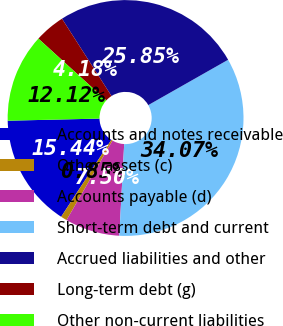Convert chart. <chart><loc_0><loc_0><loc_500><loc_500><pie_chart><fcel>Accounts and notes receivable<fcel>Other assets (c)<fcel>Accounts payable (d)<fcel>Short-term debt and current<fcel>Accrued liabilities and other<fcel>Long-term debt (g)<fcel>Other non-current liabilities<nl><fcel>15.44%<fcel>0.85%<fcel>7.5%<fcel>34.07%<fcel>25.85%<fcel>4.18%<fcel>12.12%<nl></chart> 